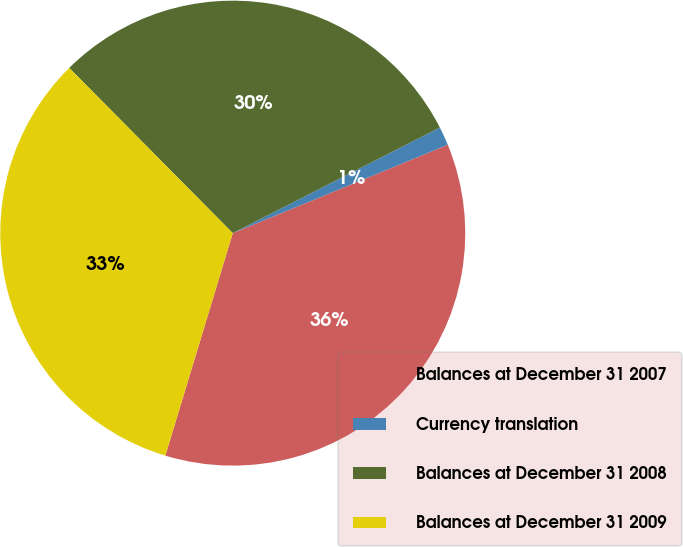Convert chart. <chart><loc_0><loc_0><loc_500><loc_500><pie_chart><fcel>Balances at December 31 2007<fcel>Currency translation<fcel>Balances at December 31 2008<fcel>Balances at December 31 2009<nl><fcel>35.89%<fcel>1.3%<fcel>29.91%<fcel>32.9%<nl></chart> 